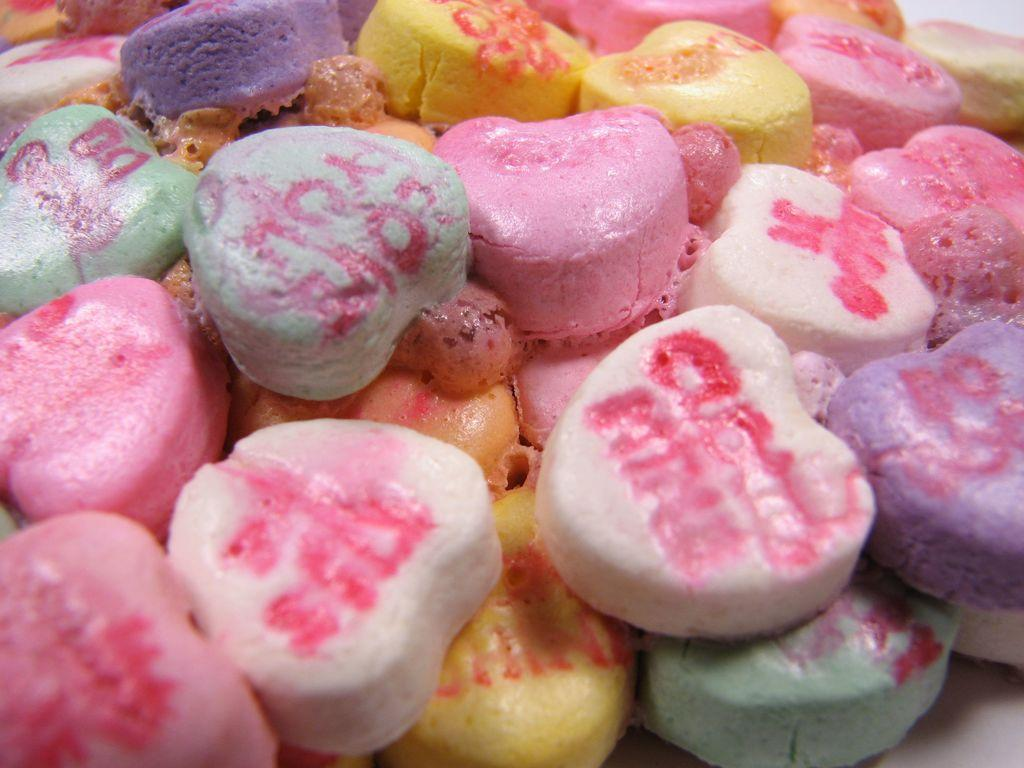What type of food items are present in the image? There are candies in the image. How many different colors can be seen among the candies? The candies are in different colors. How are the candies arranged in the image? The candies are arranged in the image. What color is the background of the image? The background of the image is white. How is the bone being transported in the image? There is no bone present in the image, so it cannot be transported. 